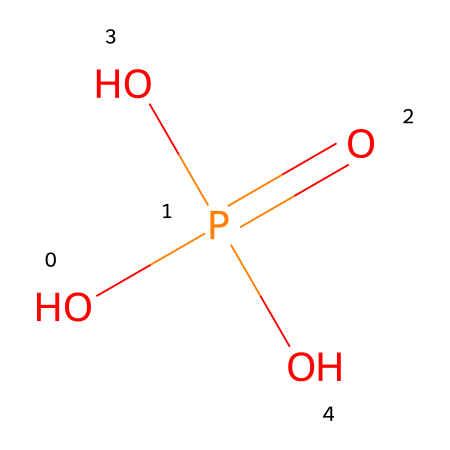What is the chemical name of this compound? The SMILES representation indicates it is phosphoric acid, which is a common phosphorus-containing compound.
Answer: phosphoric acid How many oxygen atoms are in the structure? By examining the SMILES representation, there are four oxygen atoms present, as denoted by 'O's in the formula.
Answer: four What is the oxidation state of phosphorus in this compound? Phosphorus typically has an oxidation state of +5 in phosphoric acid, due to its four bonds with oxygen atoms, which are all more electronegative than phosphorus.
Answer: +5 How many hydrogen atoms are present in the structure? The SMILES representation indicates three hydrogen atoms (attached to three of the four oxygen atoms), accounting for their presence in the molecular formula.
Answer: three What type of acid is phosphoric acid classified as? Phosphoric acid is classified as a weak acid due to its partial ionization in aqueous solution, which can be inferred from its molecular structure and the presence of multiple acidic protons.
Answer: weak acid What property of phosphoric acid makes it a common ingredient in cola drinks? Phosphoric acid provides tartness and enhances flavor in beverages, which is evident from its role in food and drinks, including cola.
Answer: tartness 